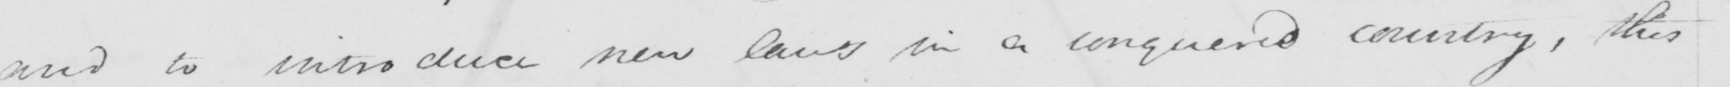What text is written in this handwritten line? and to introduce new laws in a conquered country , this 